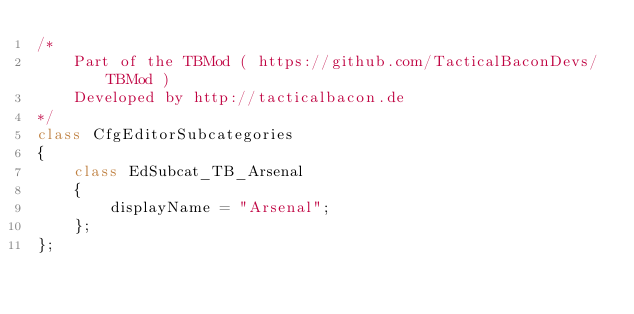Convert code to text. <code><loc_0><loc_0><loc_500><loc_500><_C++_>/*
    Part of the TBMod ( https://github.com/TacticalBaconDevs/TBMod )
    Developed by http://tacticalbacon.de
*/
class CfgEditorSubcategories
{
    class EdSubcat_TB_Arsenal
    {
        displayName = "Arsenal";
    };
};
</code> 